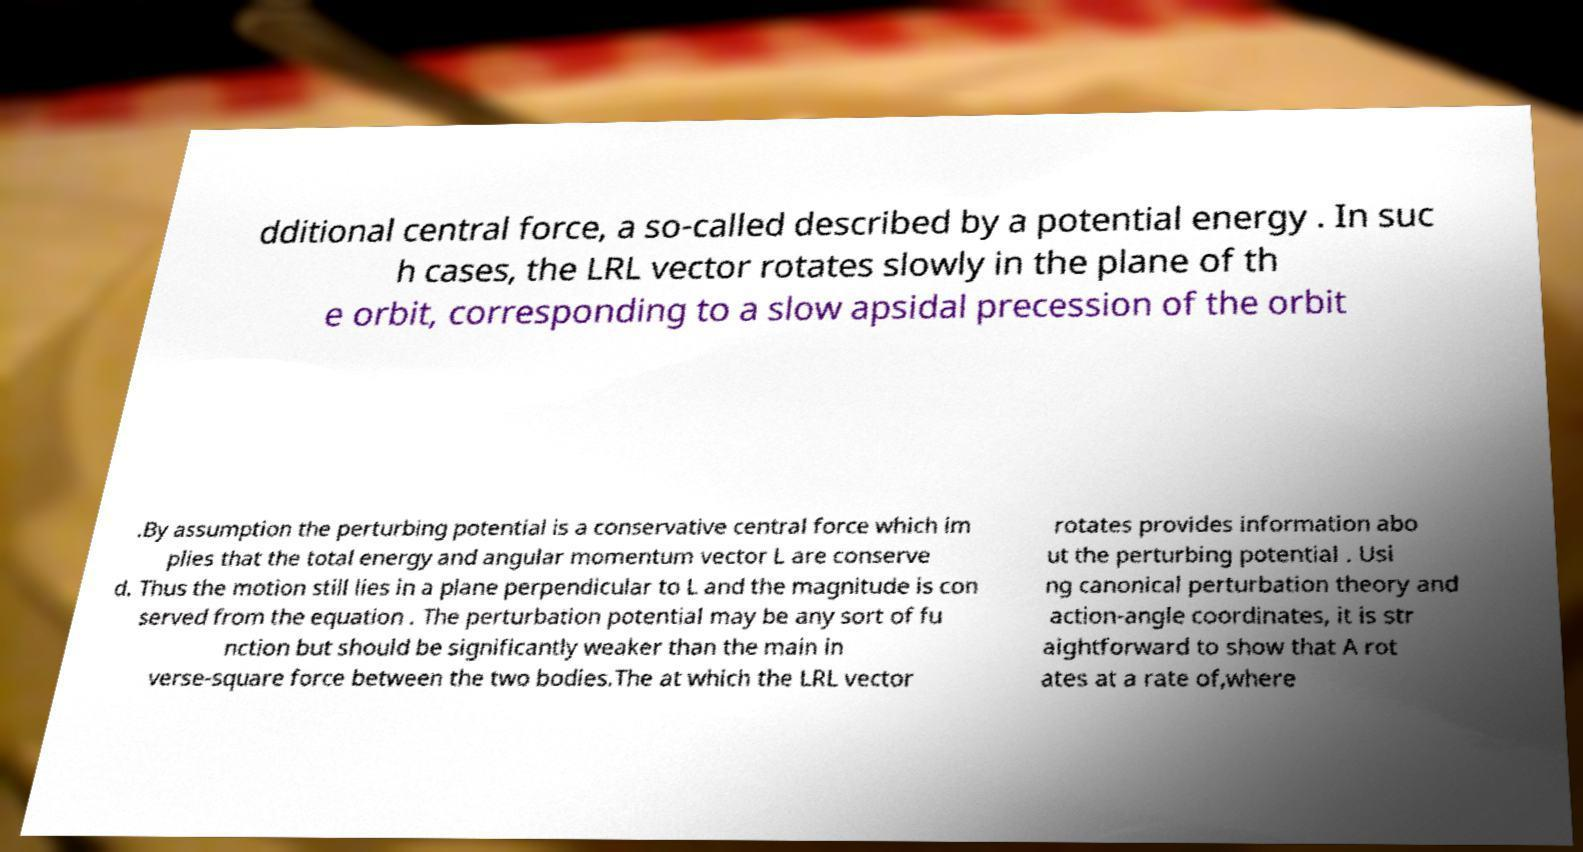Please read and relay the text visible in this image. What does it say? dditional central force, a so-called described by a potential energy . In suc h cases, the LRL vector rotates slowly in the plane of th e orbit, corresponding to a slow apsidal precession of the orbit .By assumption the perturbing potential is a conservative central force which im plies that the total energy and angular momentum vector L are conserve d. Thus the motion still lies in a plane perpendicular to L and the magnitude is con served from the equation . The perturbation potential may be any sort of fu nction but should be significantly weaker than the main in verse-square force between the two bodies.The at which the LRL vector rotates provides information abo ut the perturbing potential . Usi ng canonical perturbation theory and action-angle coordinates, it is str aightforward to show that A rot ates at a rate of,where 